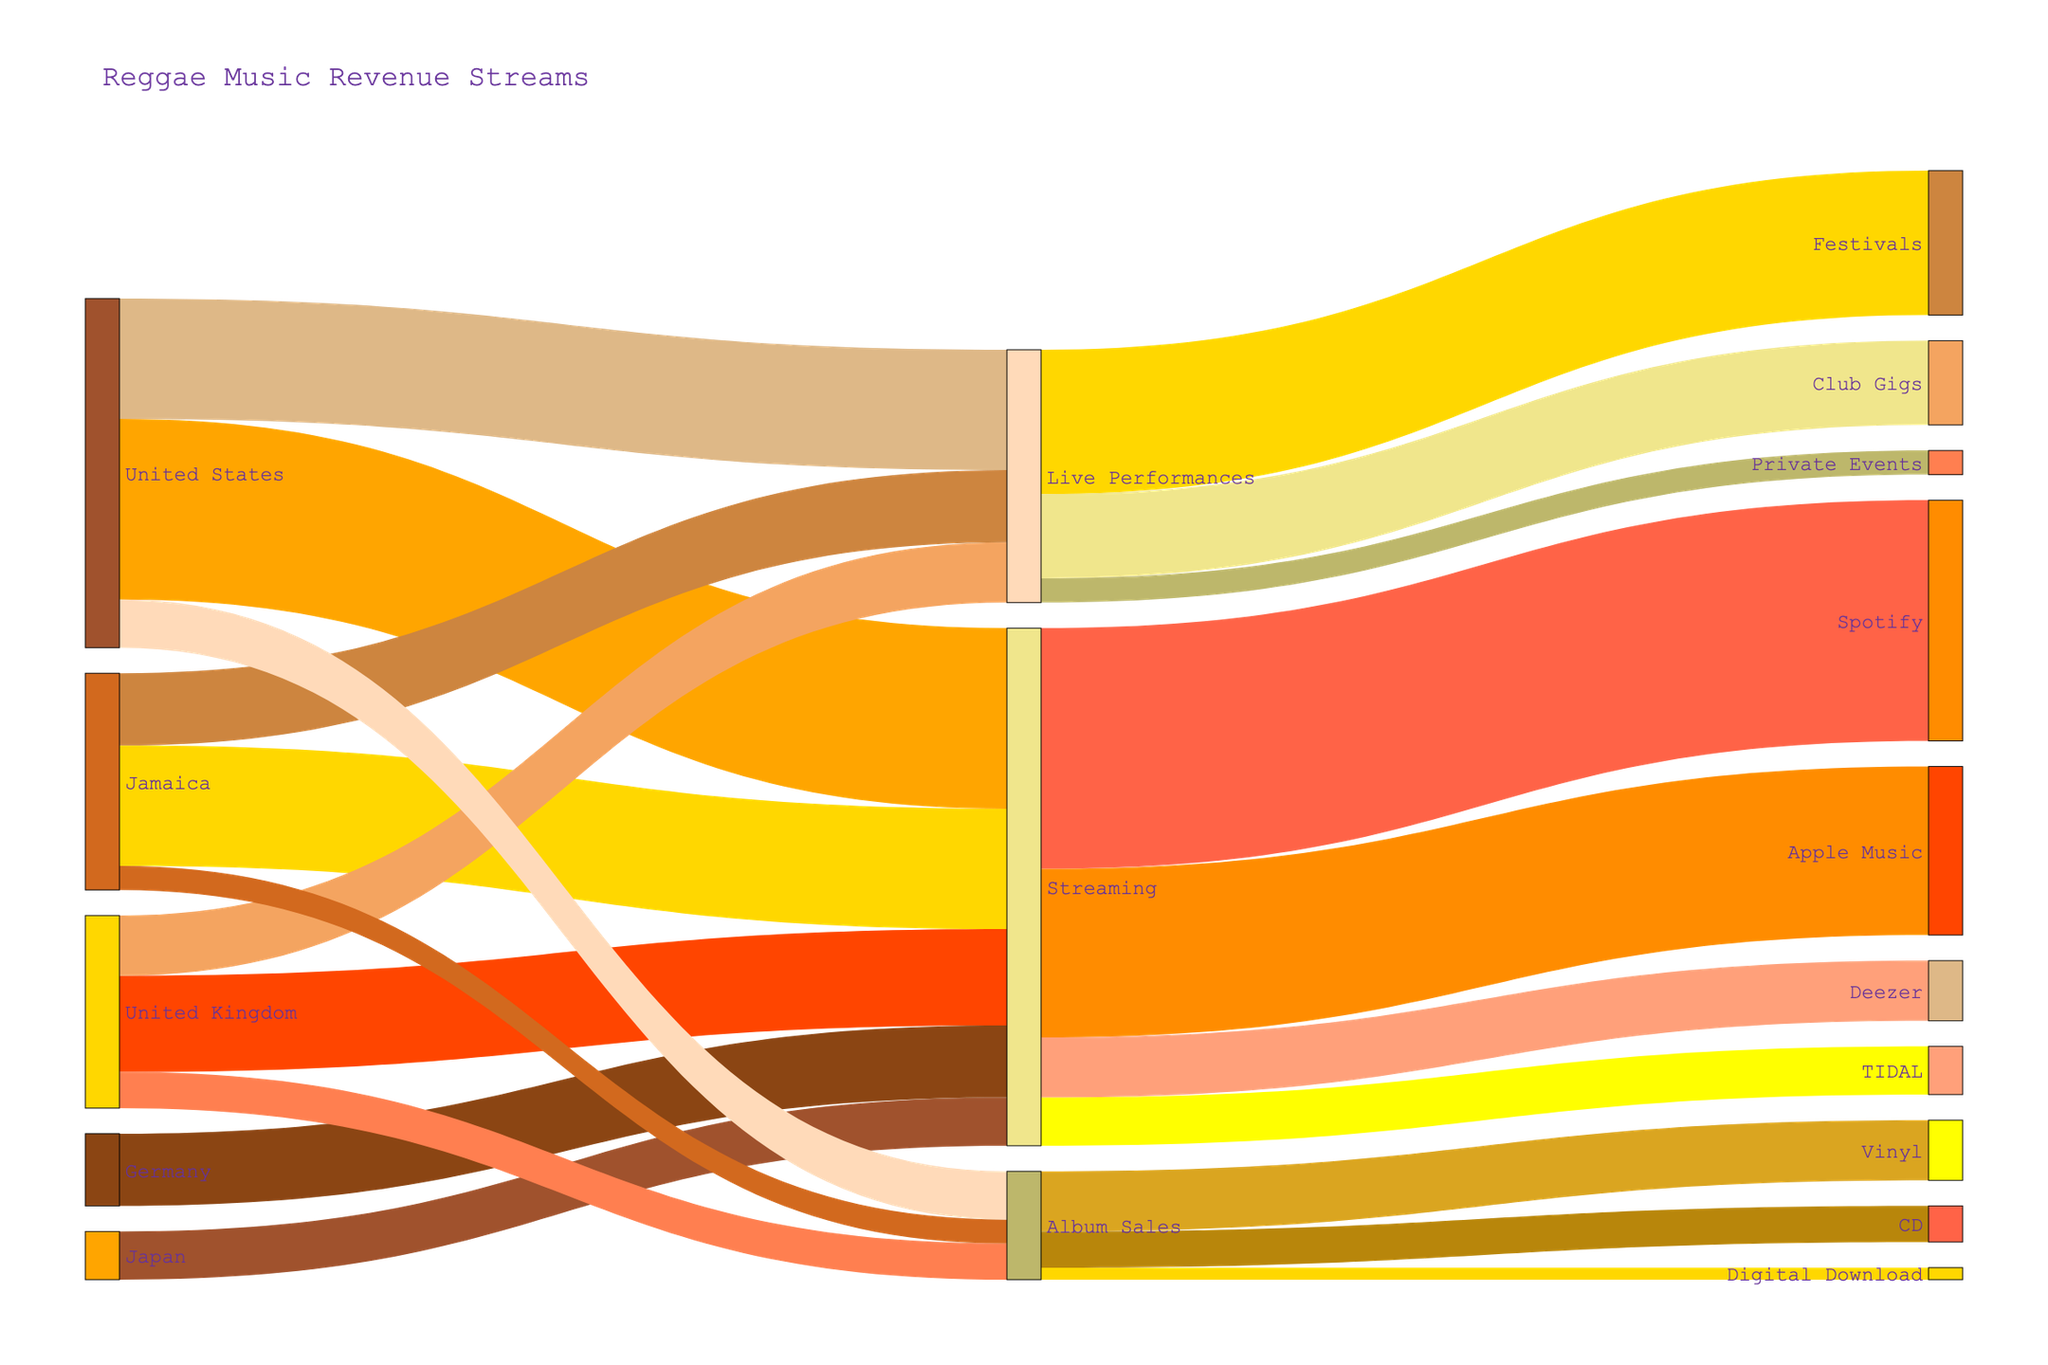How many total revenue streams are visualized in the diagram? There are three main revenue streams starting from the initial countries: Streaming, Live Performances, and Album Sales.
Answer: 3 Which country generates the highest revenue through streaming? By comparing the values of revenue through streaming from each country, the United States has the highest revenue of 750,000.
Answer: United States What is the total revenue from album sales across all countries? Summing the values for Album Sales from Jamaica, the United States, and the United Kingdom, we get 100,000 + 200,000 + 150,000 = 450,000.
Answer: 450,000 Which music platform receives the most streaming revenue? Among Spotify, Apple Music, Deezer, and TIDAL, Spotify receives the highest revenue of 1,000,000.
Answer: Spotify Compare the revenue from Jamaica's Live Performances to the United States' Live Performances. Which is higher and by how much? The revenue from Jamaica's Live Performances is 300,000, while the United States' Live Performances is 500,000. The difference is 500,000 - 300,000 = 200,000.
Answer: United States by 200,000 What is the combined revenue of Club Gigs and Private Events? Adding the values for Club Gigs (350,000) and Private Events (100,000) gives 350,000 + 100,000 = 450,000.
Answer: 450,000 How does the total revenue from Live Performances compare to the revenue from Streaming across all countries? The total revenue from Live Performances is 1,050,000 (summing 300,000, 500,000, and 250,000), and the revenue from Streaming is 2,150,000 (summing 500,000, 750,000, 400,000, 300,000, and 200,000).
Answer: Streaming is higher by 1,100,000 What is the least significant revenue source within Album Sales, and what is its value? Among Vinyl, CD, and Digital Download, Digital Download has the lowest revenue with a value of 50,000.
Answer: Digital Download with 50,000 Which entity has a revenue stream of exactly 600,000? Within Live Performances, Festivals generate a revenue of exactly 600,000.
Answer: Festivals Calculate the total revenue generated from Japan. The revenue from Japan is only in the Streaming category, and it is 200,000.
Answer: 200,000 